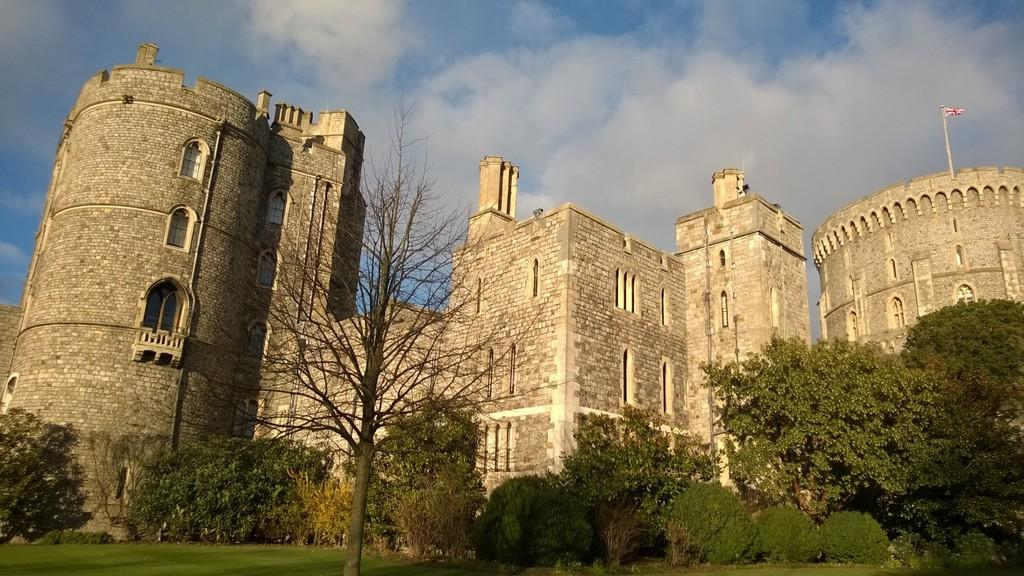What type of structure is in the image? There is a fort in the image. What is on top of the fort? There is a flag on the fort. What can be seen in the front of the image? Trees and grass are visible in the front of the image. What is visible in the background of the image? The sky is visible in the background of the image. What type of plastic is used to make the yard in the image? There is no plastic yard present in the image; it features a fort with trees and grass in the front. Is the image taken during the night or day? The time of day cannot be determined from the image, as there is no specific information about lighting or shadows. 